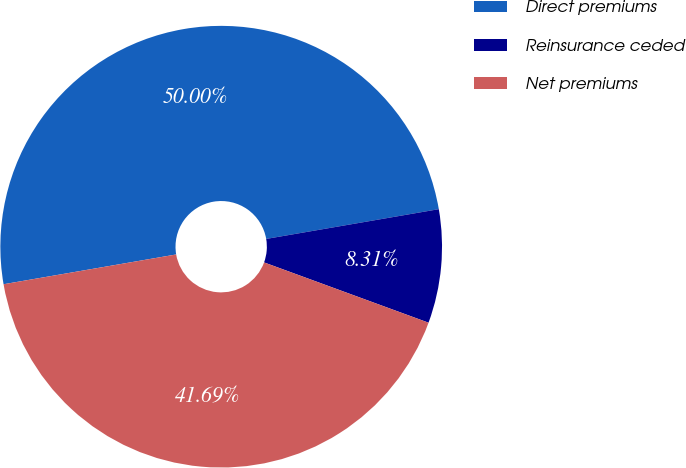Convert chart. <chart><loc_0><loc_0><loc_500><loc_500><pie_chart><fcel>Direct premiums<fcel>Reinsurance ceded<fcel>Net premiums<nl><fcel>50.0%<fcel>8.31%<fcel>41.69%<nl></chart> 